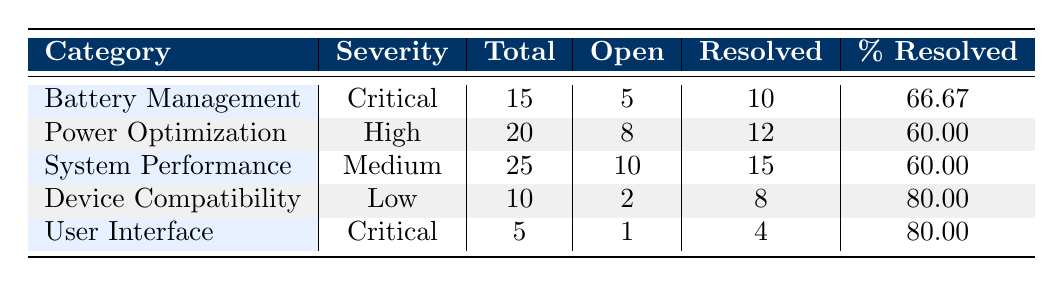What is the total number of bug reports for 'Battery Management'? The table shows that the total number of bug reports for the 'Battery Management' category is listed under the 'Total' column. It states a total of 15 reports.
Answer: 15 How many open bug reports are there in the 'User Interface' category? The 'User Interface' category lists its open reports in the 'Open' column, which shows a count of 1.
Answer: 1 Which category has the highest percentage of resolved reports? To find the highest percentage resolved, compare the values in the '% Resolved' column across all categories. 'Device Compatibility' and 'User Interface' both show 80, which is the highest.
Answer: Device Compatibility and User Interface What is the average number of total reports across all categories? To calculate the average, sum the total reports (15 + 20 + 25 + 10 + 5 = 75) and divide by the number of categories (5). So, 75 / 5 = 15.
Answer: 15 Are there any categories with no open reports? Check the 'Open' column for each category. Each category has at least some open reports, confirming that there are none with zero open reports.
Answer: No What is the difference in the number of resolved reports between 'Power Optimization' and 'Battery Management'? The resolved reports for 'Power Optimization' is 12 and for 'Battery Management' is 10. Calculate the difference by subtracting: 12 - 10 = 2.
Answer: 2 If we combine the total reports of 'System Performance' and 'Device Compatibility', what will be the overall total? To find this, add the total reports of 'System Performance' (25) and 'Device Compatibility' (10): 25 + 10 = 35.
Answer: 35 What fraction of the total reports in 'Battery Management' have been resolved? 'Battery Management' has 10 resolved reports out of 15 total reports. This fraction is 10/15, which simplifies to 2/3.
Answer: 2/3 Which severity categories are present for the reports? The severity categories listed in the table are Critical, High, Medium, and Low, found in the 'Severity' column.
Answer: Critical, High, Medium, Low 